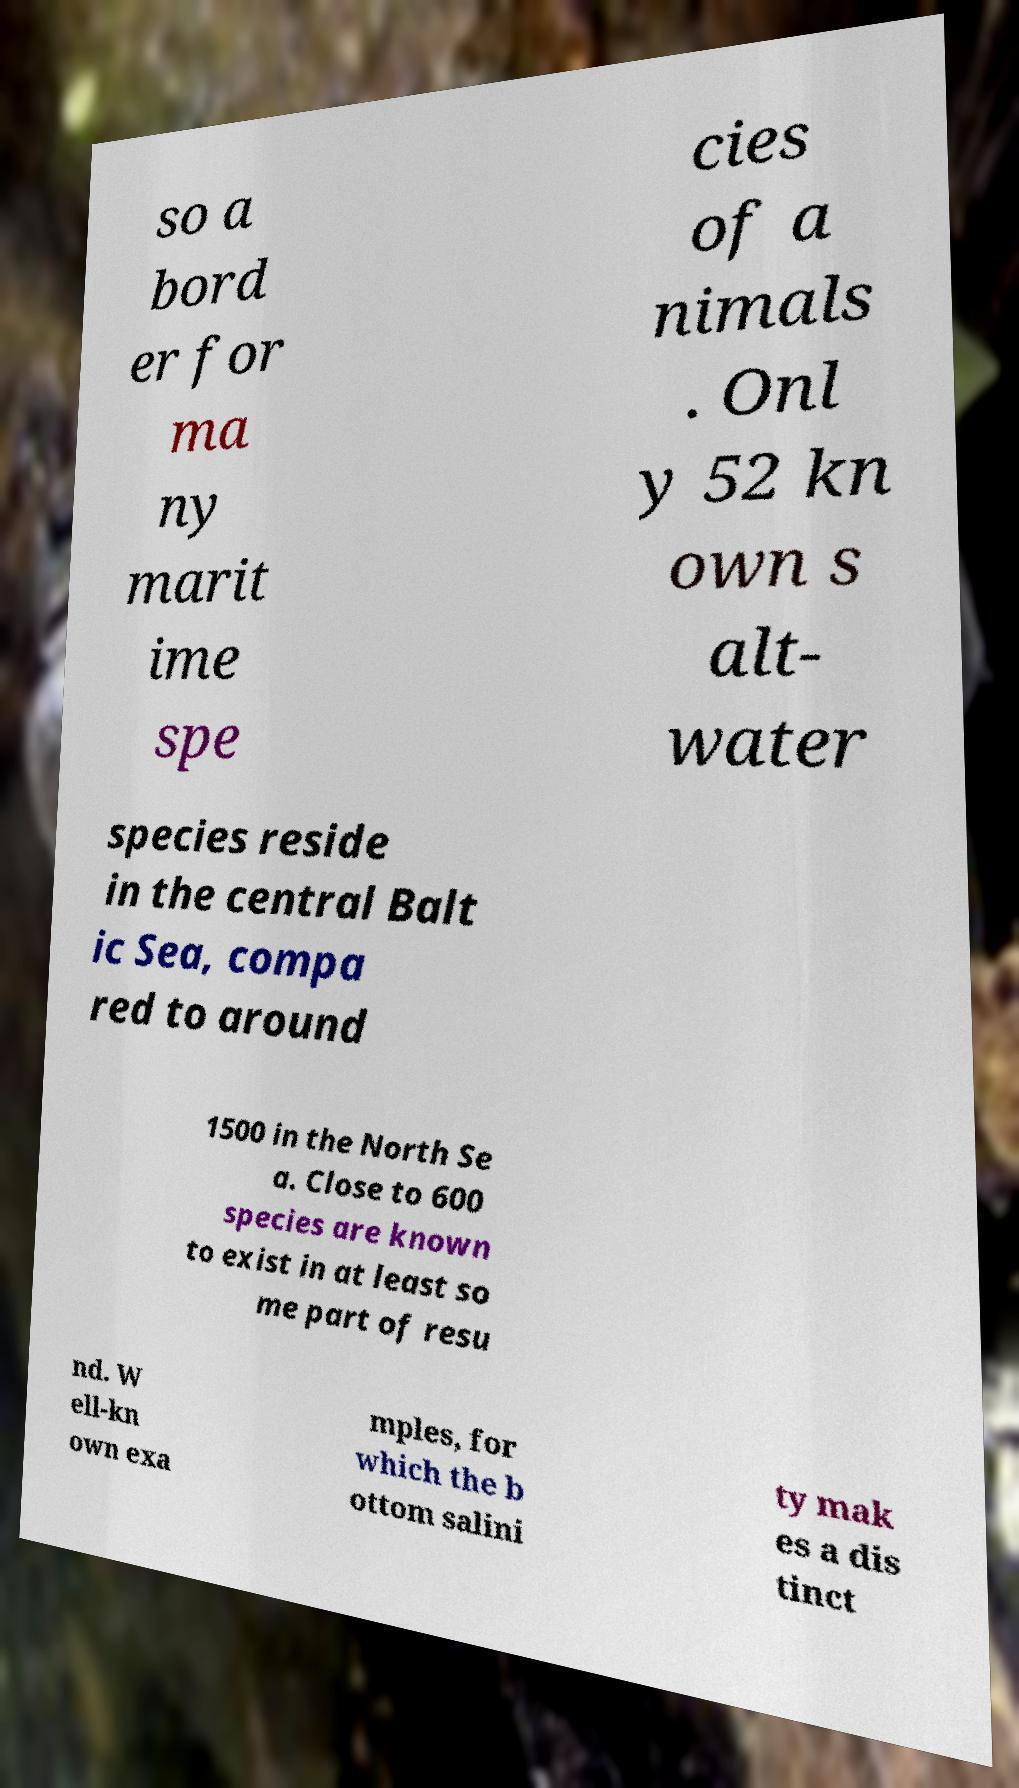Could you extract and type out the text from this image? so a bord er for ma ny marit ime spe cies of a nimals . Onl y 52 kn own s alt- water species reside in the central Balt ic Sea, compa red to around 1500 in the North Se a. Close to 600 species are known to exist in at least so me part of resu nd. W ell-kn own exa mples, for which the b ottom salini ty mak es a dis tinct 